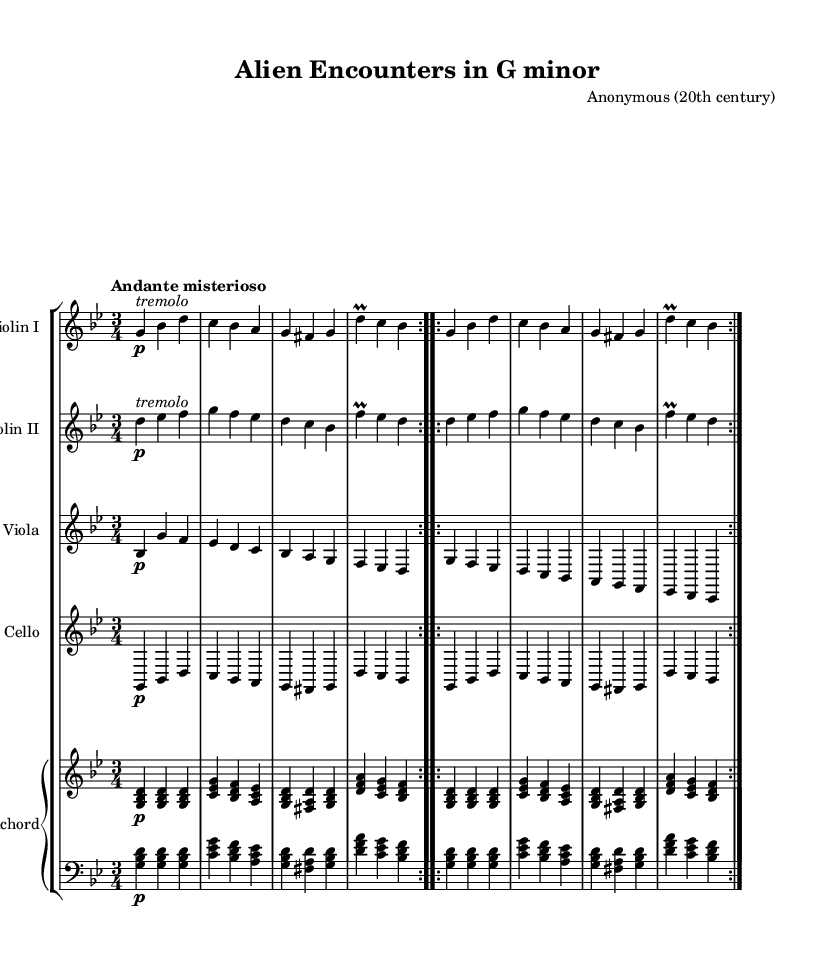What is the key signature of this music? The key signature of the piece is G minor, which typically has two flats: B flat and E flat. This can be identified at the beginning of the staff where the key signature is indicated.
Answer: G minor What is the time signature of this music? The time signature is 3/4, as noted at the beginning of the sheet music. This means there are three beats in each measure and a quarter note receives one beat.
Answer: 3/4 What is the tempo marking for this piece? The tempo marking is "Andante misterioso," suggesting a moderate pace with a mysterious character. This is written above the staff and describes how the music should be played.
Answer: Andante misterioso How many violins are present in this composition? There are two violins in this composition, as indicated by the two staves labeled "Violin I" and "Violin II."
Answer: Two What is the form of the piece? The piece is structured in a repeat format, as noted by the "\repeat volta 2" markings, which indicate sections that are to be played twice. This form is common in Baroque music.
Answer: Repeat Which instrument plays a continuo role in this chamber music? The harpsichord plays the continuo role, providing harmonic support and rhythm, which is typical in Baroque chamber ensembles. This is identified by the staff labeled "Harpsichord."
Answer: Harpsichord What is the dynamic marking for the first violin part? The dynamic marking for the first violin part is "p," indicating that it should be played piano, or softly. This is shown at the start of its phrases.
Answer: p 